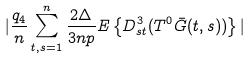<formula> <loc_0><loc_0><loc_500><loc_500>| \frac { q _ { 4 } } { n } \sum _ { t , s = 1 } ^ { n } \frac { 2 \Delta } { 3 n p } { E } \left \{ D ^ { 3 } _ { s t } ( T ^ { 0 } \bar { G } ( t , s ) ) \right \} |</formula> 